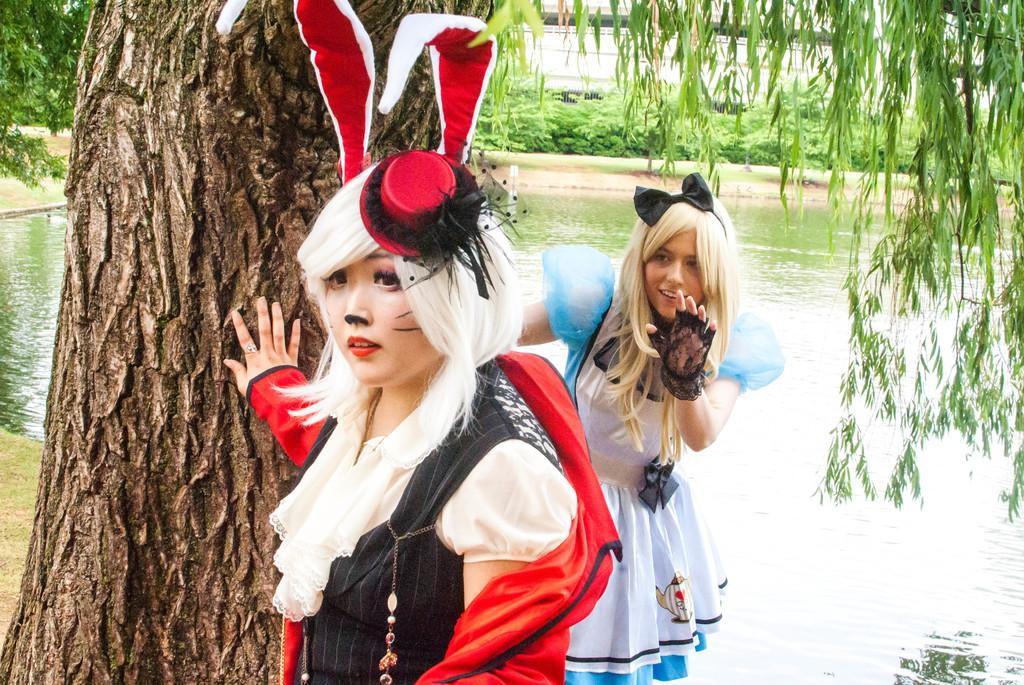How many women are in the image? There are 2 women in the image. What are the women wearing? The women are wearing costumes. What can be seen in the image besides the women? There is water visible in the image, as well as a tree and plants in the background. What book is the woman holding in the image? There is no book visible in the image. 